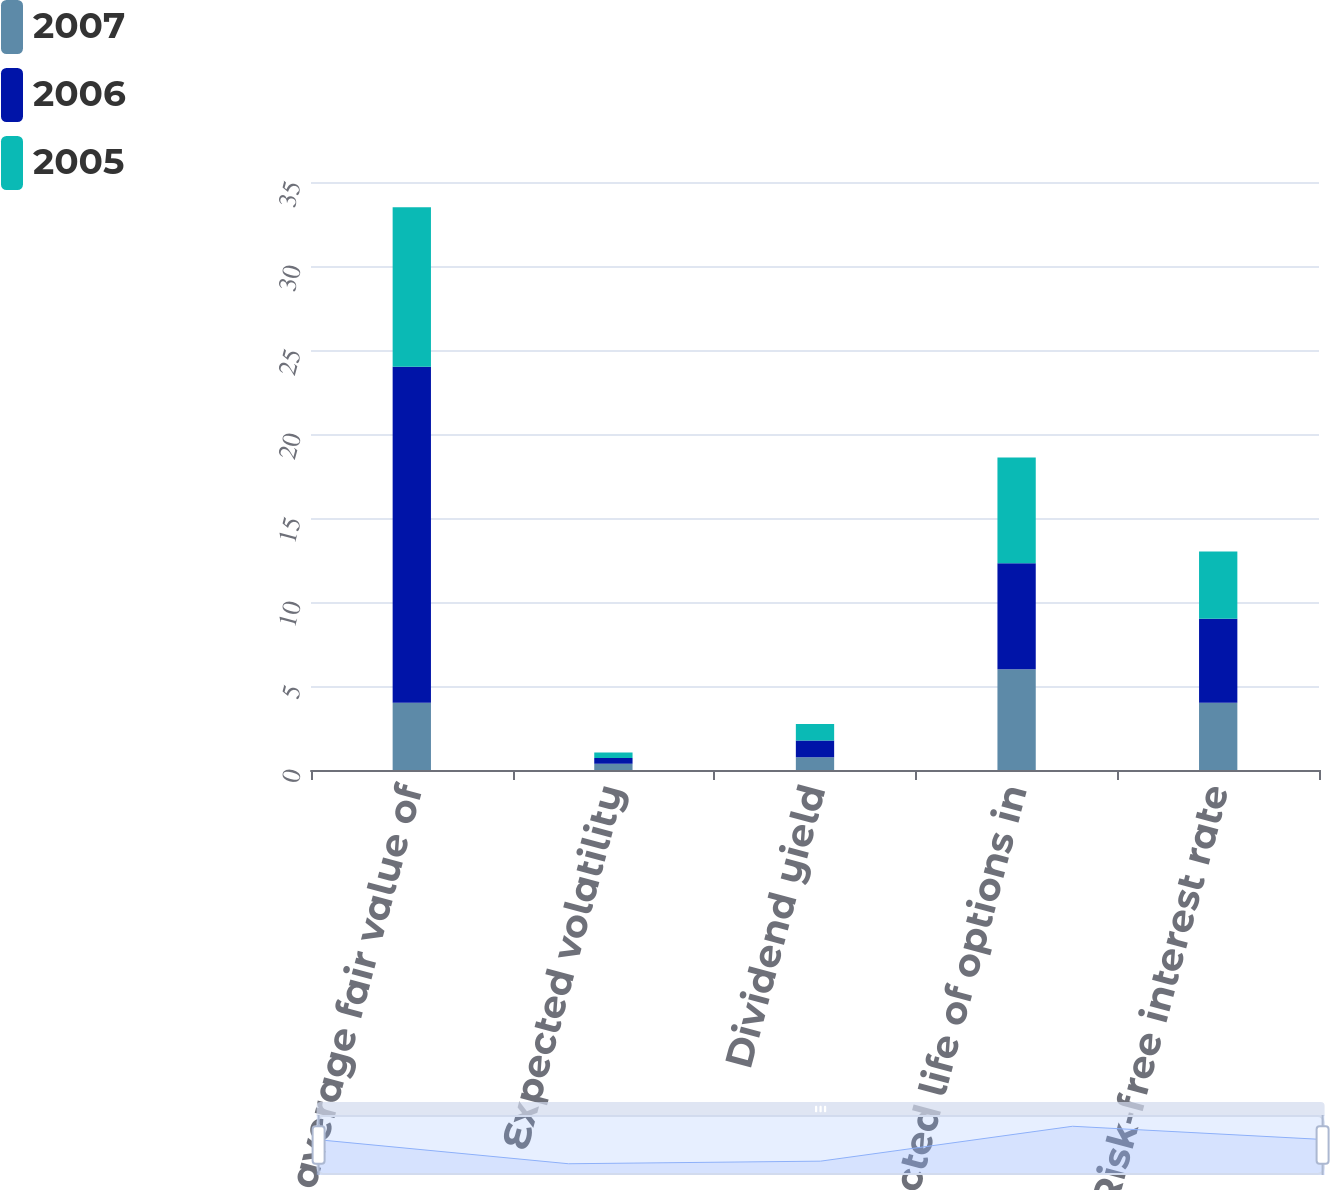<chart> <loc_0><loc_0><loc_500><loc_500><stacked_bar_chart><ecel><fcel>Weighted average fair value of<fcel>Expected volatility<fcel>Dividend yield<fcel>Expected life of options in<fcel>Risk-free interest rate<nl><fcel>2007<fcel>4<fcel>0.37<fcel>0.76<fcel>6<fcel>4<nl><fcel>2006<fcel>20.01<fcel>0.35<fcel>1<fcel>6.3<fcel>5<nl><fcel>2005<fcel>9.48<fcel>0.32<fcel>0.98<fcel>6.3<fcel>4<nl></chart> 